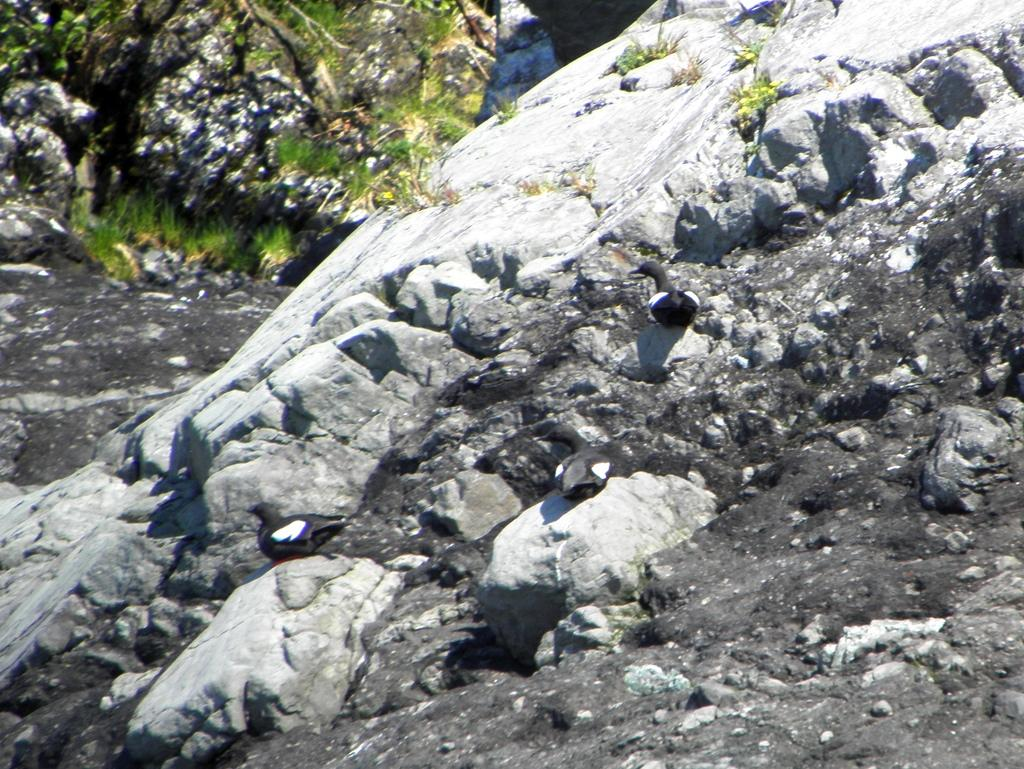What type of surface can be seen in the image? Ground is visible in the image. What can be found on the ground in the image? Rocks are present on the ground. What type of animals are in the image? There are birds in the image. What else is present in the image besides the ground, rocks, and birds? Plants are present in the image. What type of vessel is being used by the birds in the image? There is no vessel present in the image, and the birds are not using any vessel. 